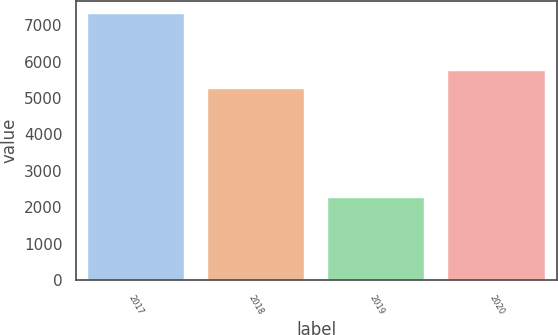Convert chart to OTSL. <chart><loc_0><loc_0><loc_500><loc_500><bar_chart><fcel>2017<fcel>2018<fcel>2019<fcel>2020<nl><fcel>7305<fcel>5243<fcel>2243<fcel>5749.2<nl></chart> 